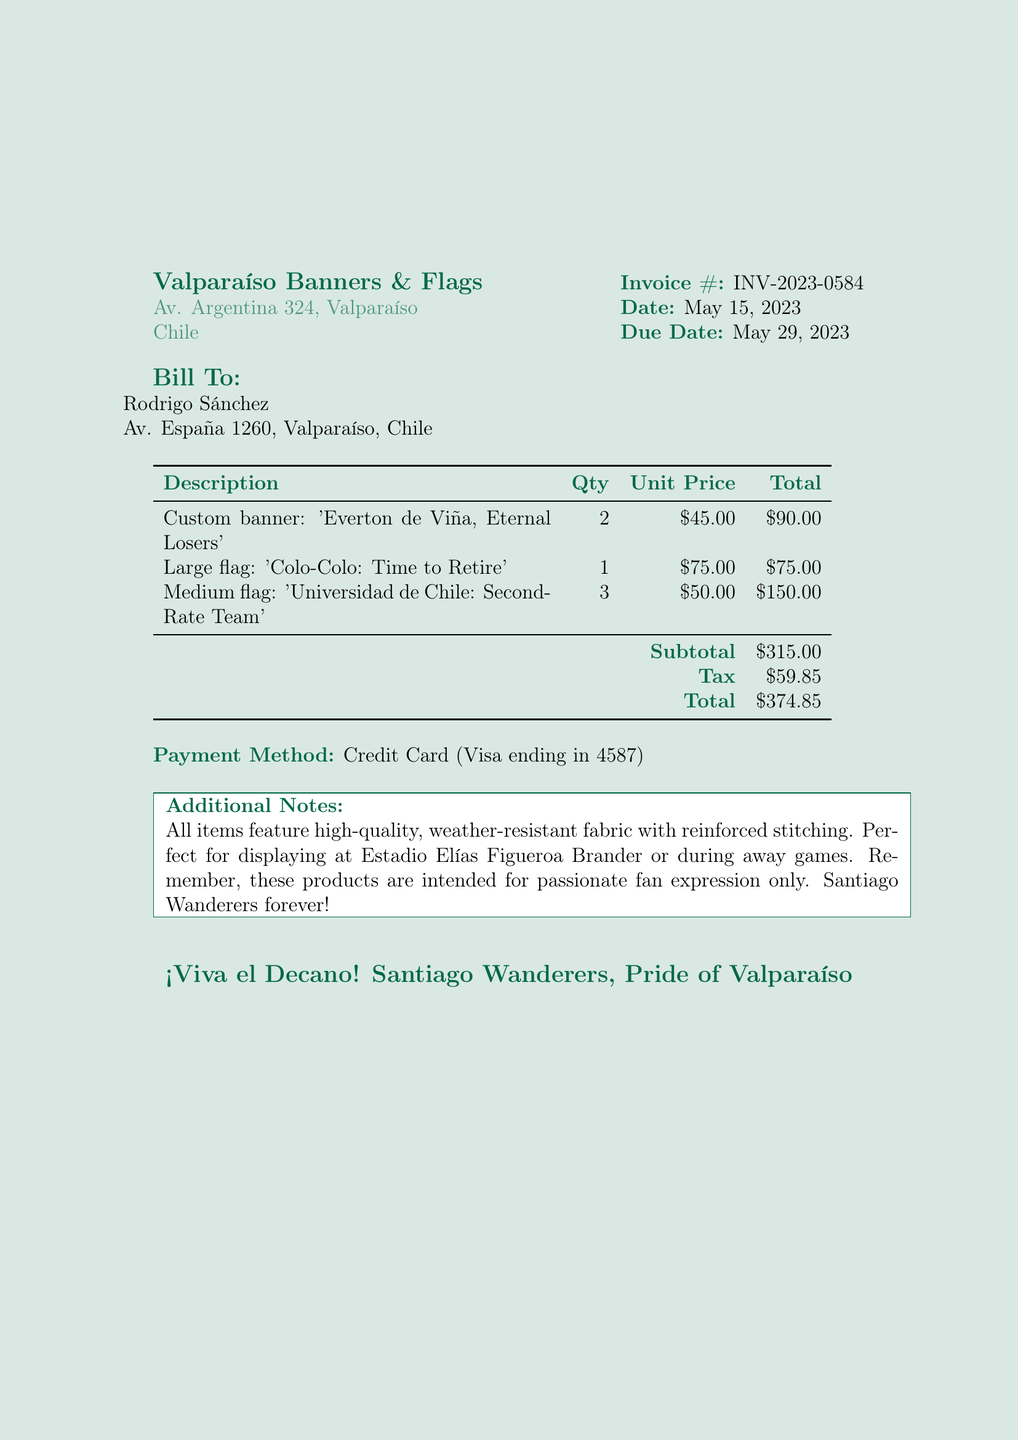What is the company name? The company name listed on the invoice is Valparaíso Banners & Flags.
Answer: Valparaíso Banners & Flags What is the invoice number? The invoice number is clearly stated on the document as INV-2023-0584.
Answer: INV-2023-0584 What is the total amount due? The total amount due, which is the final amount after tax, is $374.85 as indicated on the invoice.
Answer: $374.85 How many custom banners are ordered? The document specifies that 2 custom banners are ordered with the description provided.
Answer: 2 What is the description of the large flag? The large flag has a specific description mentioned in the invoice stating 'Colo-Colo: Time to Retire'.
Answer: Colo-Colo: Time to Retire What is the tax amount? The tax amount is noted in the document, which totals $59.85.
Answer: $59.85 When is the due date for the invoice? The due date for the invoice is listed as May 29, 2023.
Answer: May 29, 2023 What fabric quality is mentioned for the items? The invoice mentions that all items are made of high-quality, weather-resistant fabric with reinforced stitching.
Answer: high-quality, weather-resistant fabric How many medium flags are included in the order? According to the order items, 3 medium flags have been ordered, as detailed in the document.
Answer: 3 What payment method is used? The payment method specified in the document is Credit Card (Visa ending in 4587).
Answer: Credit Card (Visa ending in 4587) 